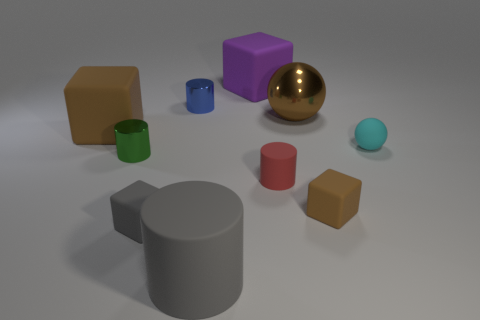There is a brown cube right of the green metal thing; is its size the same as the brown metal ball?
Ensure brevity in your answer.  No. How big is the metal object that is left of the red matte thing and in front of the blue object?
Your answer should be very brief. Small. What number of other things are there of the same shape as the big purple thing?
Your answer should be very brief. 3. What number of other things are the same material as the gray cube?
Ensure brevity in your answer.  6. What is the size of the green metal object that is the same shape as the small red matte thing?
Provide a succinct answer. Small. Is the large metal sphere the same color as the big rubber cylinder?
Make the answer very short. No. There is a tiny cylinder that is in front of the small cyan ball and right of the green metallic object; what color is it?
Give a very brief answer. Red. How many objects are tiny cylinders in front of the cyan object or tiny cyan rubber spheres?
Provide a succinct answer. 3. The small rubber thing that is the same shape as the large gray rubber object is what color?
Keep it short and to the point. Red. Do the red object and the large brown thing that is on the left side of the big purple object have the same shape?
Your response must be concise. No. 